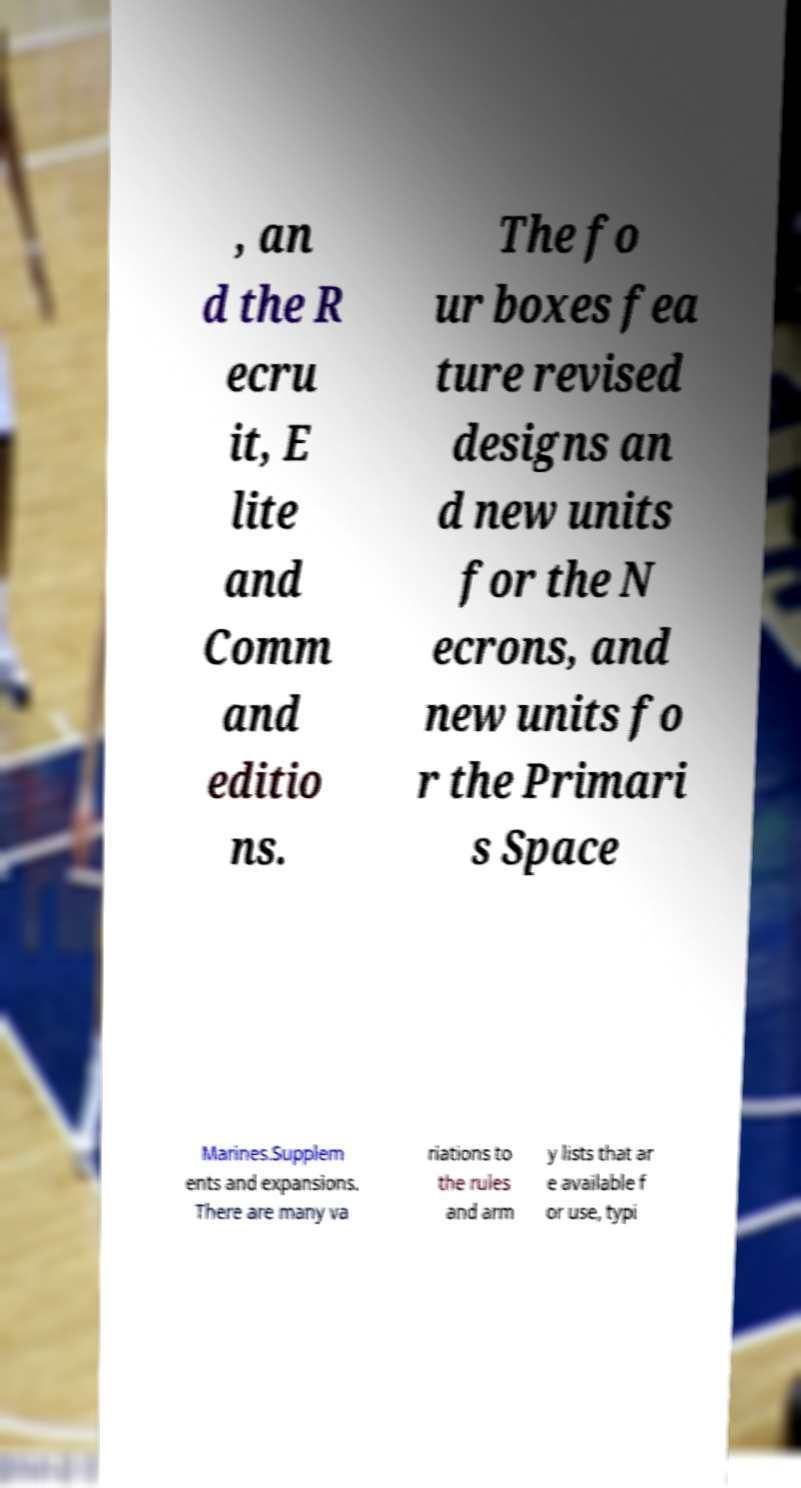Please identify and transcribe the text found in this image. , an d the R ecru it, E lite and Comm and editio ns. The fo ur boxes fea ture revised designs an d new units for the N ecrons, and new units fo r the Primari s Space Marines.Supplem ents and expansions. There are many va riations to the rules and arm y lists that ar e available f or use, typi 